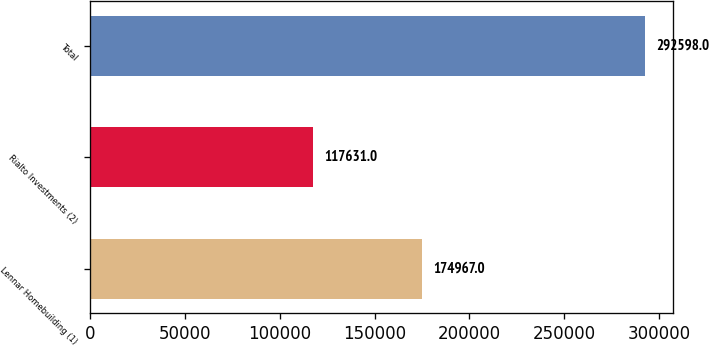<chart> <loc_0><loc_0><loc_500><loc_500><bar_chart><fcel>Lennar Homebuilding (1)<fcel>Rialto Investments (2)<fcel>Total<nl><fcel>174967<fcel>117631<fcel>292598<nl></chart> 